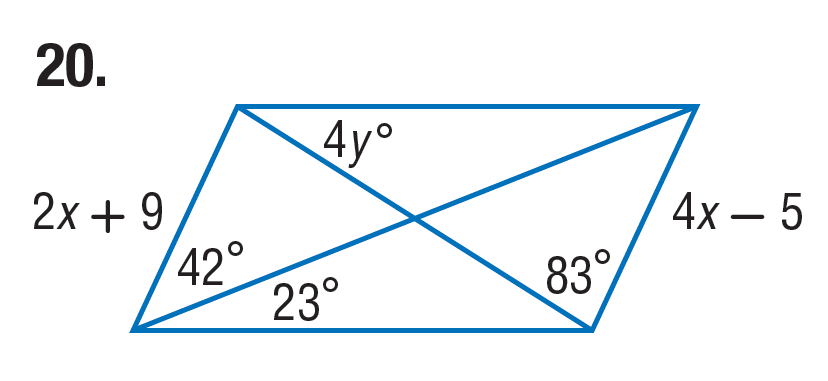Answer the mathemtical geometry problem and directly provide the correct option letter.
Question: Find x in the parallelogram.
Choices: A: 7 B: 14 C: 15 D: 23 A 